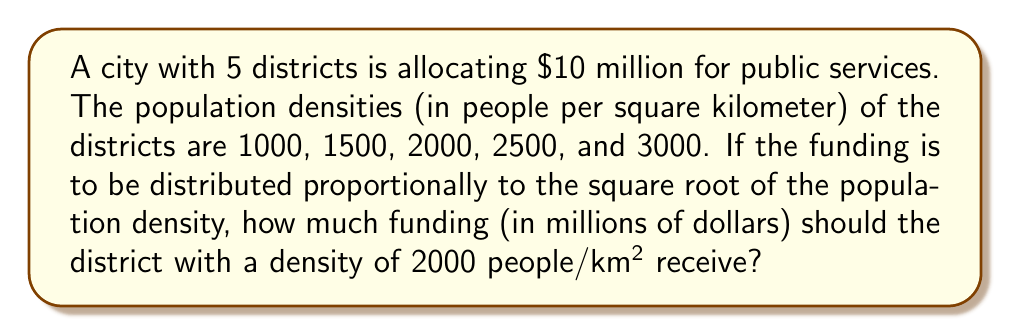Can you answer this question? Let's approach this step-by-step:

1) First, we need to calculate the square root of each district's population density:

   $$\sqrt{1000} \approx 31.62$$
   $$\sqrt{1500} \approx 38.73$$
   $$\sqrt{2000} = 44.72$$
   $$\sqrt{2500} = 50.00$$
   $$\sqrt{3000} \approx 54.77$$

2) Now, we sum these square roots to get the total:

   $$31.62 + 38.73 + 44.72 + 50.00 + 54.77 = 219.84$$

3) To find the proportion for the district with density 2000, we divide its square root by the total:

   $$\frac{44.72}{219.84} \approx 0.2034$$

4) Since the total funding is $10 million, we multiply this proportion by 10:

   $$0.2034 \times 10 \approx 2.034$$

Therefore, the district with a density of 2000 people/km² should receive approximately $2.034 million.
Answer: $2.034 million 